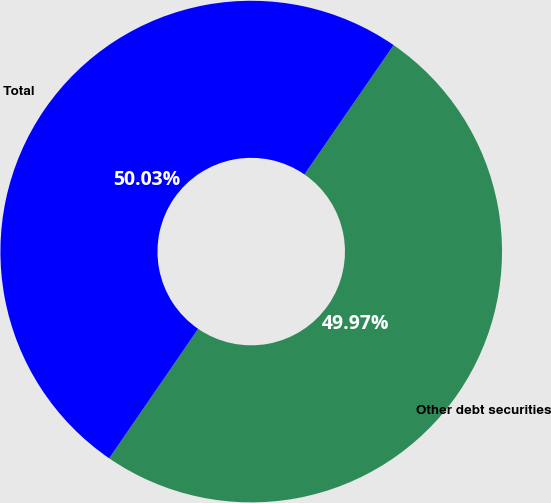<chart> <loc_0><loc_0><loc_500><loc_500><pie_chart><fcel>Other debt securities<fcel>Total<nl><fcel>49.97%<fcel>50.03%<nl></chart> 